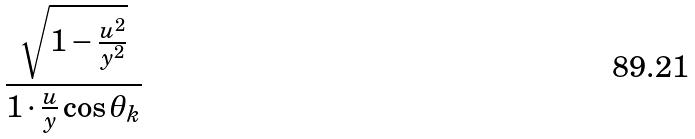Convert formula to latex. <formula><loc_0><loc_0><loc_500><loc_500>\frac { \sqrt { 1 - \frac { u ^ { 2 } } { y ^ { 2 } } } } { 1 \cdot \frac { u } { y } \cos \theta _ { k } }</formula> 